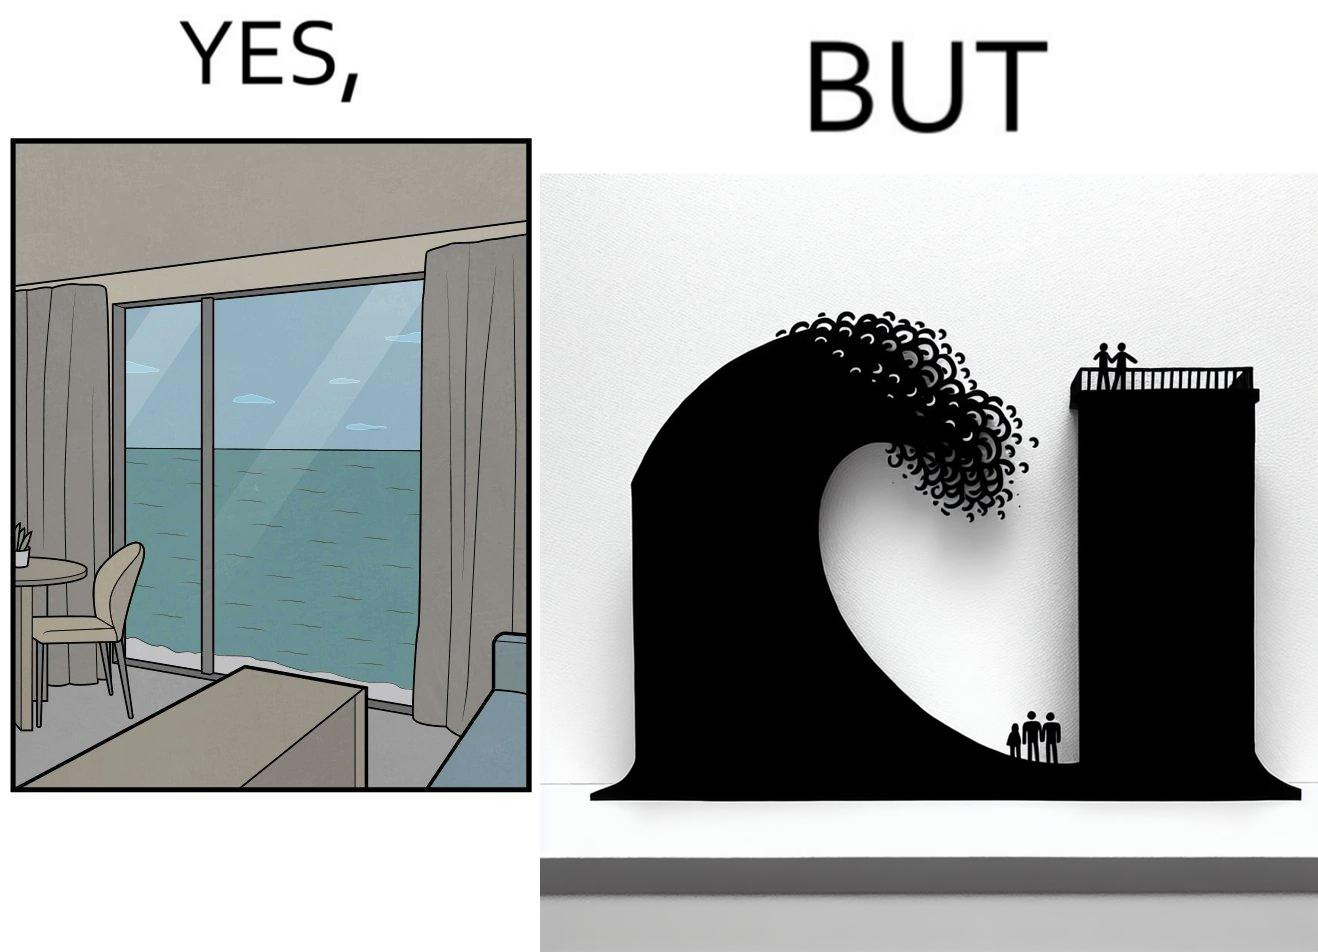What makes this image funny or satirical? The same sea which gives us a relaxation on a normal day can pose a danger to us sometimes like during a tsunami 